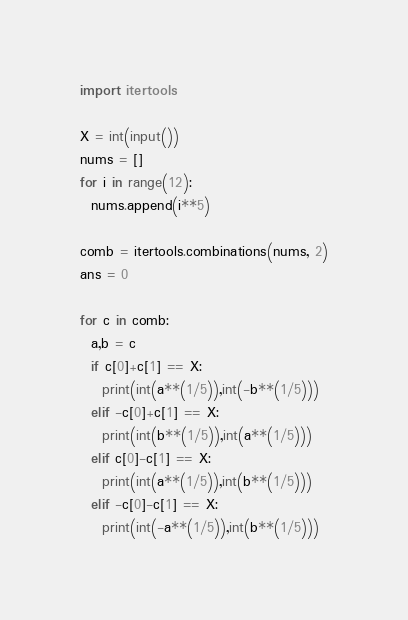Convert code to text. <code><loc_0><loc_0><loc_500><loc_500><_Python_>import itertools

X = int(input())
nums = []
for i in range(12):
  nums.append(i**5)

comb = itertools.combinations(nums, 2)
ans = 0

for c in comb:
  a,b = c
  if c[0]+c[1] == X:
    print(int(a**(1/5)),int(-b**(1/5)))
  elif -c[0]+c[1] == X:
    print(int(b**(1/5)),int(a**(1/5)))
  elif c[0]-c[1] == X:
    print(int(a**(1/5)),int(b**(1/5)))
  elif -c[0]-c[1] == X:
    print(int(-a**(1/5)),int(b**(1/5)))

</code> 